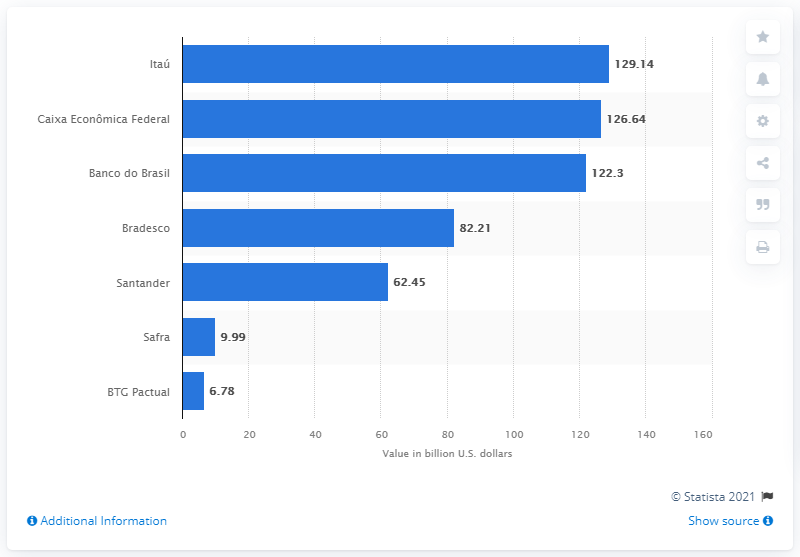Highlight a few significant elements in this photo. As of September 2019, Itaú Unibanco deposited a total of 129.14 dollars. 